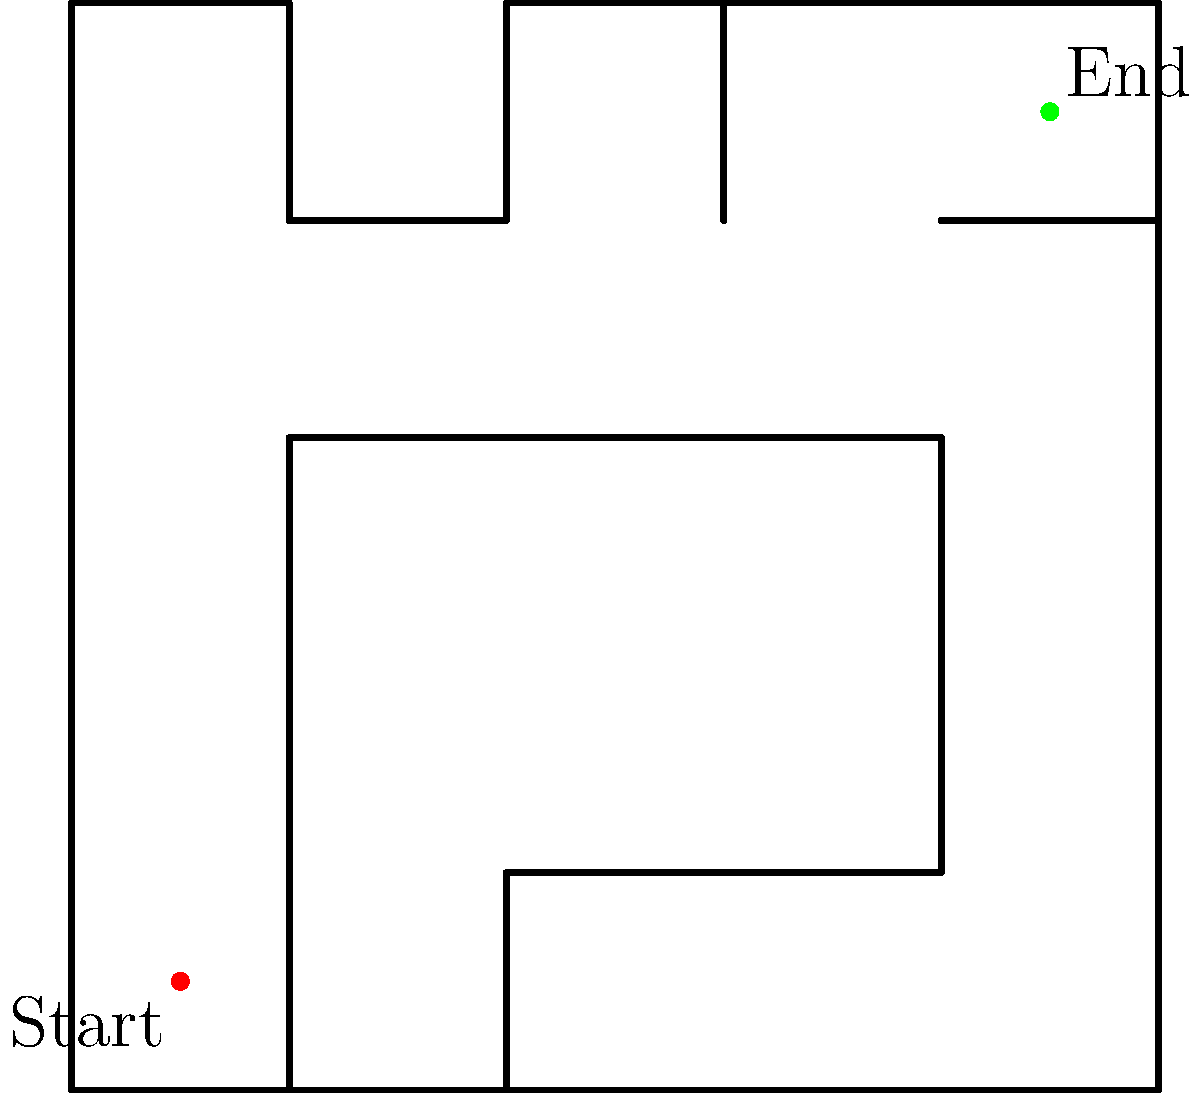As a news reporter covering urban planning initiatives, you're given a bird's-eye view of a complex maze representing a city's road network. The red dot marks the starting point, and the green dot indicates the destination. How many right-angle turns are required to navigate from the start to the end point using the shortest possible route? Let's navigate through the maze step-by-step, counting the right-angle turns:

1. Start at the red dot (0.5, 0.5).
2. Move upward to (0.5, 3.5). This is our first turn. Count: 1.
3. Turn right and move to (3.5, 3.5). Second turn. Count: 2.
4. Turn left and move up to (3.5, 4.5). Third turn. Count: 3.
5. Turn right and move to the green dot (4.5, 4.5). Fourth and final turn. Count: 4.

This route represents the shortest path from start to end, requiring exactly 4 right-angle turns.

The question tests spatial intelligence by requiring the ability to visualize and mentally navigate through a complex 2D space, identifying the most efficient route while keeping track of directional changes.
Answer: 4 turns 